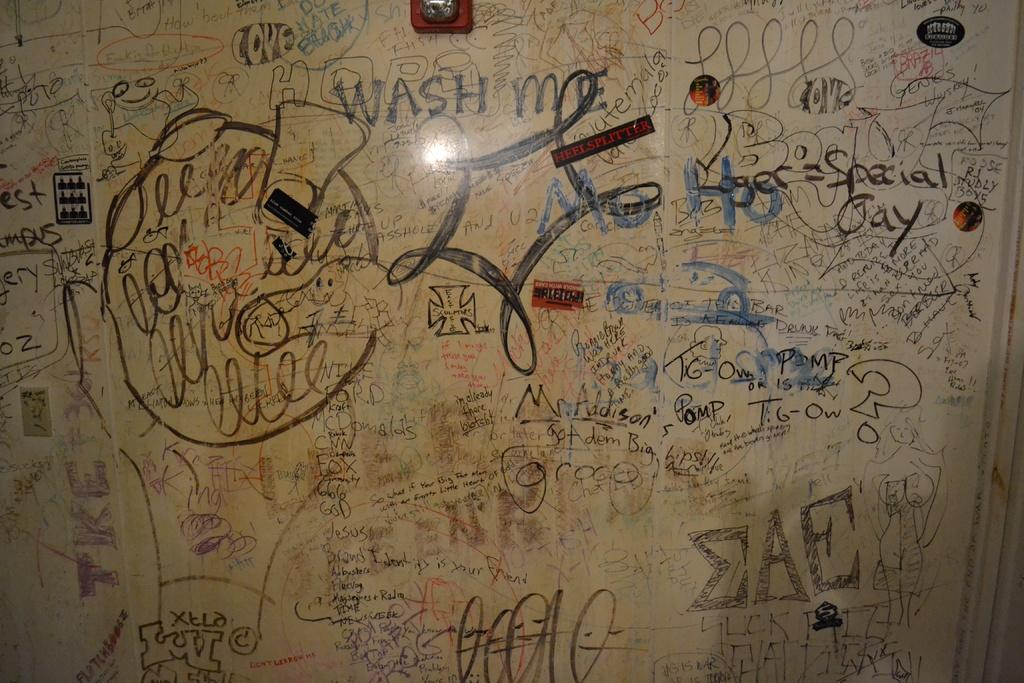<image>
Share a concise interpretation of the image provided. A wall with the words Wash me written on it 